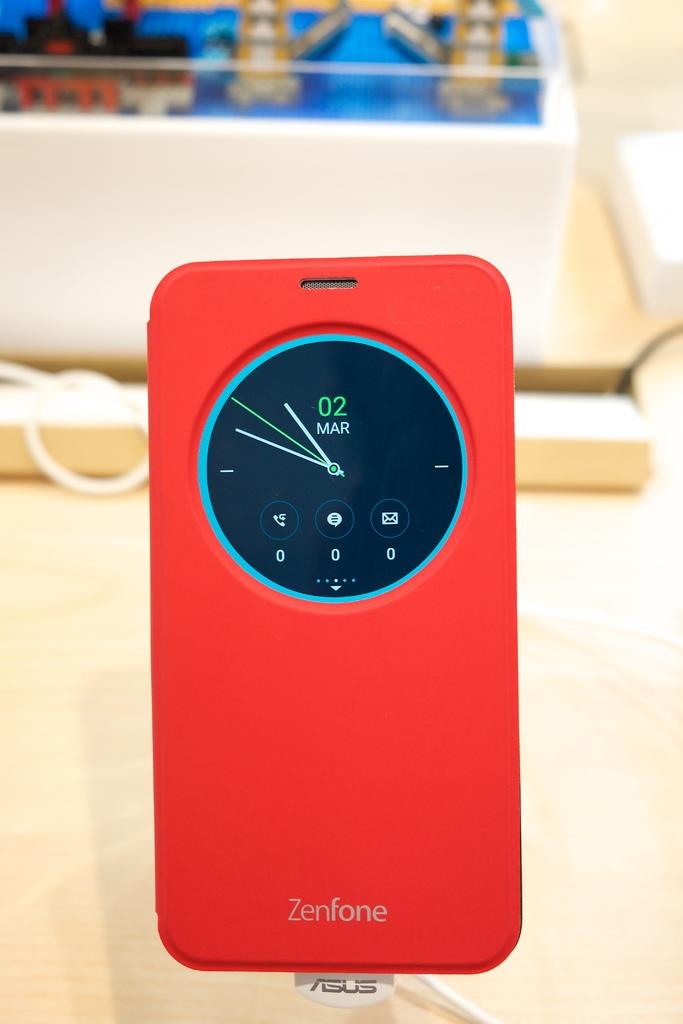What month does the phone display?
Your answer should be very brief. March. What day is it?
Your response must be concise. March 02. 